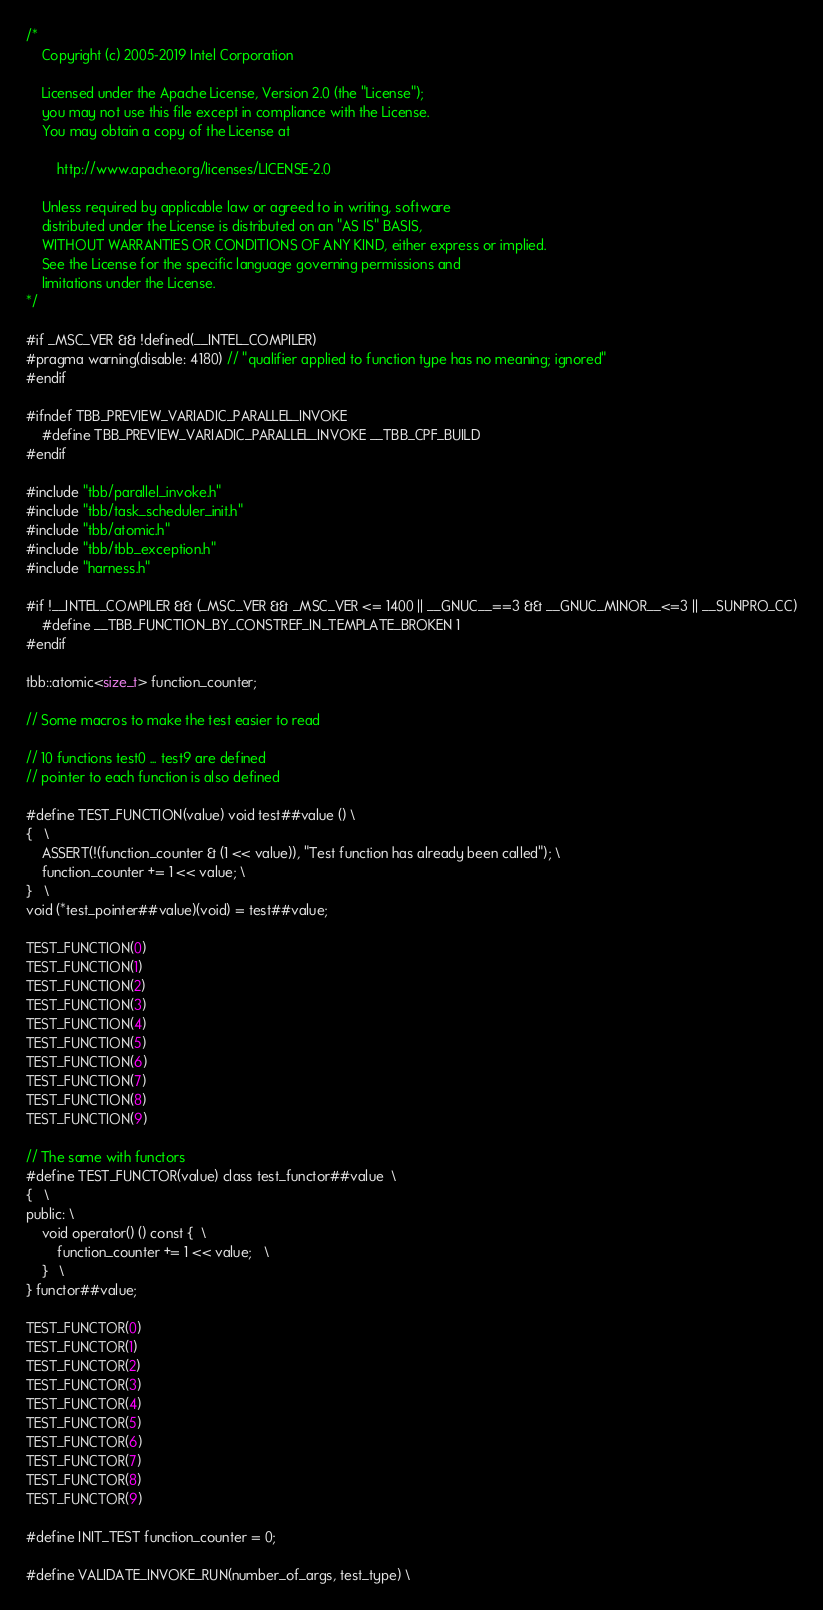<code> <loc_0><loc_0><loc_500><loc_500><_C++_>/*
    Copyright (c) 2005-2019 Intel Corporation

    Licensed under the Apache License, Version 2.0 (the "License");
    you may not use this file except in compliance with the License.
    You may obtain a copy of the License at

        http://www.apache.org/licenses/LICENSE-2.0

    Unless required by applicable law or agreed to in writing, software
    distributed under the License is distributed on an "AS IS" BASIS,
    WITHOUT WARRANTIES OR CONDITIONS OF ANY KIND, either express or implied.
    See the License for the specific language governing permissions and
    limitations under the License.
*/

#if _MSC_VER && !defined(__INTEL_COMPILER)
#pragma warning(disable: 4180) // "qualifier applied to function type has no meaning; ignored"
#endif

#ifndef TBB_PREVIEW_VARIADIC_PARALLEL_INVOKE
    #define TBB_PREVIEW_VARIADIC_PARALLEL_INVOKE __TBB_CPF_BUILD
#endif

#include "tbb/parallel_invoke.h"
#include "tbb/task_scheduler_init.h"
#include "tbb/atomic.h"
#include "tbb/tbb_exception.h"
#include "harness.h"

#if !__INTEL_COMPILER && (_MSC_VER && _MSC_VER <= 1400 || __GNUC__==3 && __GNUC_MINOR__<=3 || __SUNPRO_CC)
    #define __TBB_FUNCTION_BY_CONSTREF_IN_TEMPLATE_BROKEN 1
#endif

tbb::atomic<size_t> function_counter;

// Some macros to make the test easier to read

// 10 functions test0 ... test9 are defined
// pointer to each function is also defined

#define TEST_FUNCTION(value) void test##value () \
{   \
    ASSERT(!(function_counter & (1 << value)), "Test function has already been called"); \
    function_counter += 1 << value; \
}   \
void (*test_pointer##value)(void) = test##value;

TEST_FUNCTION(0)
TEST_FUNCTION(1)
TEST_FUNCTION(2)
TEST_FUNCTION(3)
TEST_FUNCTION(4)
TEST_FUNCTION(5)
TEST_FUNCTION(6)
TEST_FUNCTION(7)
TEST_FUNCTION(8)
TEST_FUNCTION(9)

// The same with functors
#define TEST_FUNCTOR(value) class test_functor##value  \
{   \
public: \
    void operator() () const {  \
        function_counter += 1 << value;   \
    }   \
} functor##value;

TEST_FUNCTOR(0)
TEST_FUNCTOR(1)
TEST_FUNCTOR(2)
TEST_FUNCTOR(3)
TEST_FUNCTOR(4)
TEST_FUNCTOR(5)
TEST_FUNCTOR(6)
TEST_FUNCTOR(7)
TEST_FUNCTOR(8)
TEST_FUNCTOR(9)

#define INIT_TEST function_counter = 0;

#define VALIDATE_INVOKE_RUN(number_of_args, test_type) \</code> 